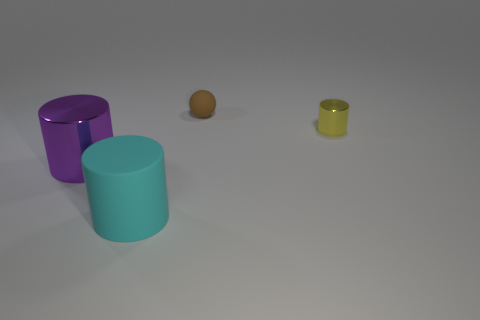What number of things are balls or purple objects that are in front of the yellow metallic cylinder? 2 